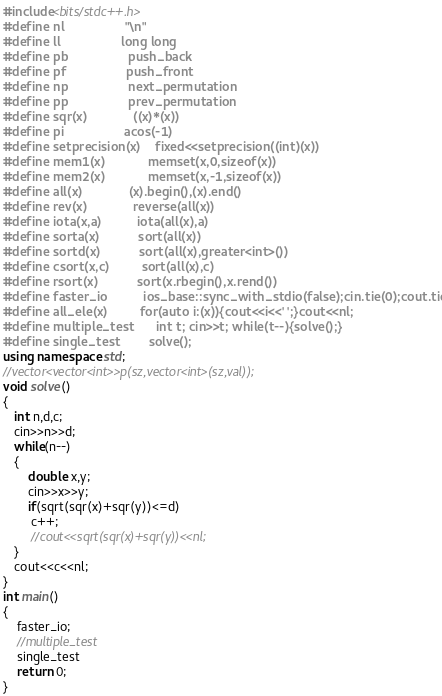<code> <loc_0><loc_0><loc_500><loc_500><_C++_>#include<bits/stdc++.h>
#define nl                 "\n"
#define ll                 long long
#define pb                 push_back
#define pf                 push_front
#define np                 next_permutation
#define pp                 prev_permutation
#define sqr(x)             ((x)*(x))
#define pi                 acos(-1)
#define setprecision(x)    fixed<<setprecision((int)(x))
#define mem1(x)            memset(x,0,sizeof(x))
#define mem2(x)            memset(x,-1,sizeof(x))
#define all(x)             (x).begin(),(x).end()
#define rev(x)             reverse(all(x))
#define iota(x,a)          iota(all(x),a)
#define sorta(x)           sort(all(x))
#define sortd(x)           sort(all(x),greater<int>())
#define csort(x,c)         sort(all(x),c)
#define rsort(x)           sort(x.rbegin(),x.rend())
#define faster_io          ios_base::sync_with_stdio(false);cin.tie(0);cout.tie(0)
#define all_ele(x)         for(auto i:(x)){cout<<i<<' ';}cout<<nl;
#define multiple_test      int t; cin>>t; while(t--){solve();}
#define single_test        solve();
using namespace std;
//vector<vector<int>>p(sz,vector<int>(sz,val));
void solve()
{
   int n,d,c;
   cin>>n>>d;
   while(n--)
   {
       double x,y;
       cin>>x>>y;
       if(sqrt(sqr(x)+sqr(y))<=d)
        c++;
        //cout<<sqrt(sqr(x)+sqr(y))<<nl;
   }
   cout<<c<<nl;
}
int main()
{
    faster_io;
    //multiple_test
    single_test
    return 0;
}


</code> 